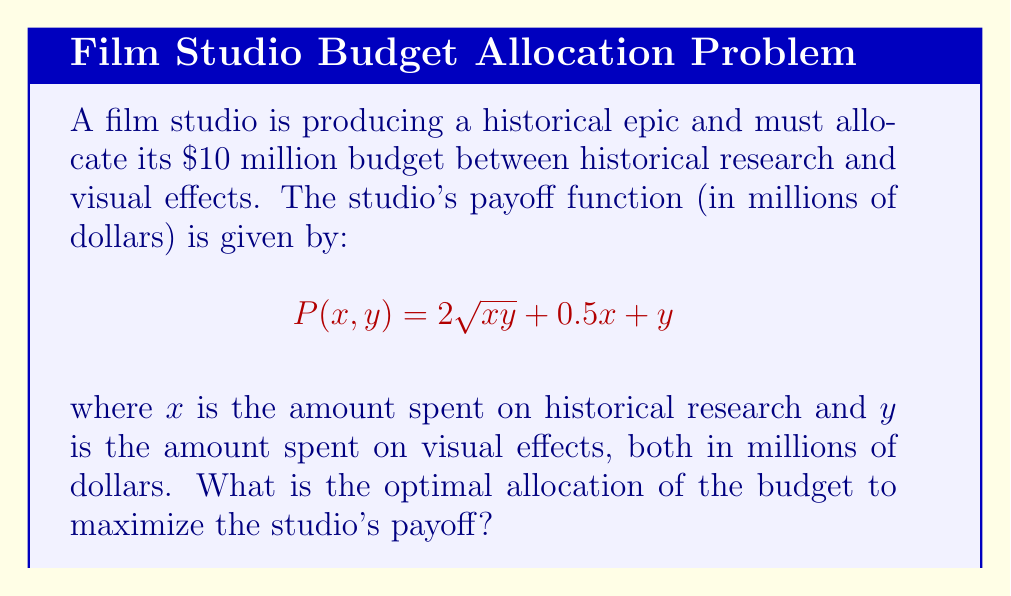Could you help me with this problem? To solve this problem, we'll use the method of Lagrange multipliers, as we have a constraint (the total budget) and we're trying to maximize a function.

1) First, let's define our constraint:
   $$x + y = 10$$

2) Now, we form the Lagrangian function:
   $$L(x, y, \lambda) = 2\sqrt{xy} + 0.5x + y - \lambda(x + y - 10)$$

3) We take partial derivatives and set them to zero:

   $$\frac{\partial L}{\partial x} = \frac{y}{\sqrt{xy}} + 0.5 - \lambda = 0$$
   
   $$\frac{\partial L}{\partial y} = \frac{x}{\sqrt{xy}} + 1 - \lambda = 0$$
   
   $$\frac{\partial L}{\partial \lambda} = x + y - 10 = 0$$

4) From the first two equations:

   $$\frac{y}{\sqrt{xy}} + 0.5 = \frac{x}{\sqrt{xy}} + 1$$

5) Simplifying:

   $$\frac{y}{\sqrt{xy}} - \frac{x}{\sqrt{xy}} = 0.5$$
   
   $$\frac{y-x}{\sqrt{xy}} = 0.5$$
   
   $$y - x = 0.5\sqrt{xy}$$

6) Squaring both sides:

   $$(y-x)^2 = 0.25xy$$
   
   $$y^2 - 2xy + x^2 = 0.25xy$$
   
   $$4y^2 - 8xy + 4x^2 = xy$$
   
   $$4y^2 - 9xy + 4x^2 = 0$$

7) Using the constraint $y = 10 - x$:

   $$4(10-x)^2 - 9x(10-x) + 4x^2 = 0$$
   
   $$400 - 80x + 4x^2 - 90x + 9x^2 + 4x^2 = 0$$
   
   $$17x^2 - 170x + 400 = 0$$

8) This is a quadratic equation. Solving it:

   $$x = \frac{170 \pm \sqrt{170^2 - 4(17)(400)}}{2(17)} = \frac{170 \pm \sqrt{28900 - 27200}}{34} = \frac{170 \pm 10\sqrt{17}}{34}$$

9) The solution that satisfies our constraint is:

   $$x = \frac{170 - 10\sqrt{17}}{34} \approx 4$$

10) Therefore, $y = 10 - x \approx 6$
Answer: The optimal allocation is approximately $4 million for historical research and $6 million for visual effects. 